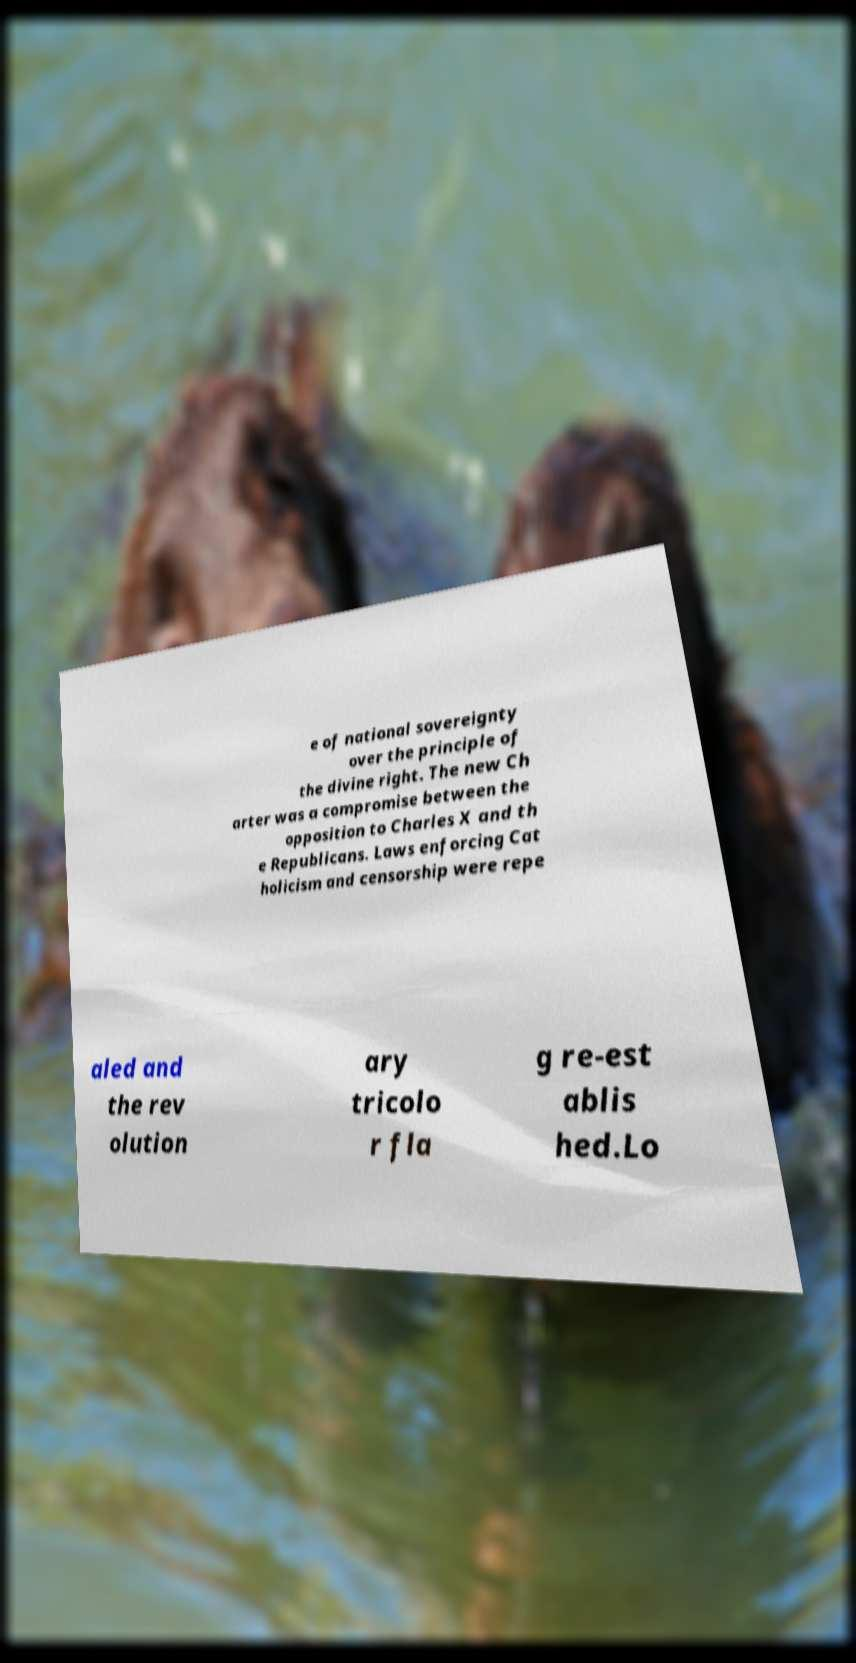Could you assist in decoding the text presented in this image and type it out clearly? e of national sovereignty over the principle of the divine right. The new Ch arter was a compromise between the opposition to Charles X and th e Republicans. Laws enforcing Cat holicism and censorship were repe aled and the rev olution ary tricolo r fla g re-est ablis hed.Lo 